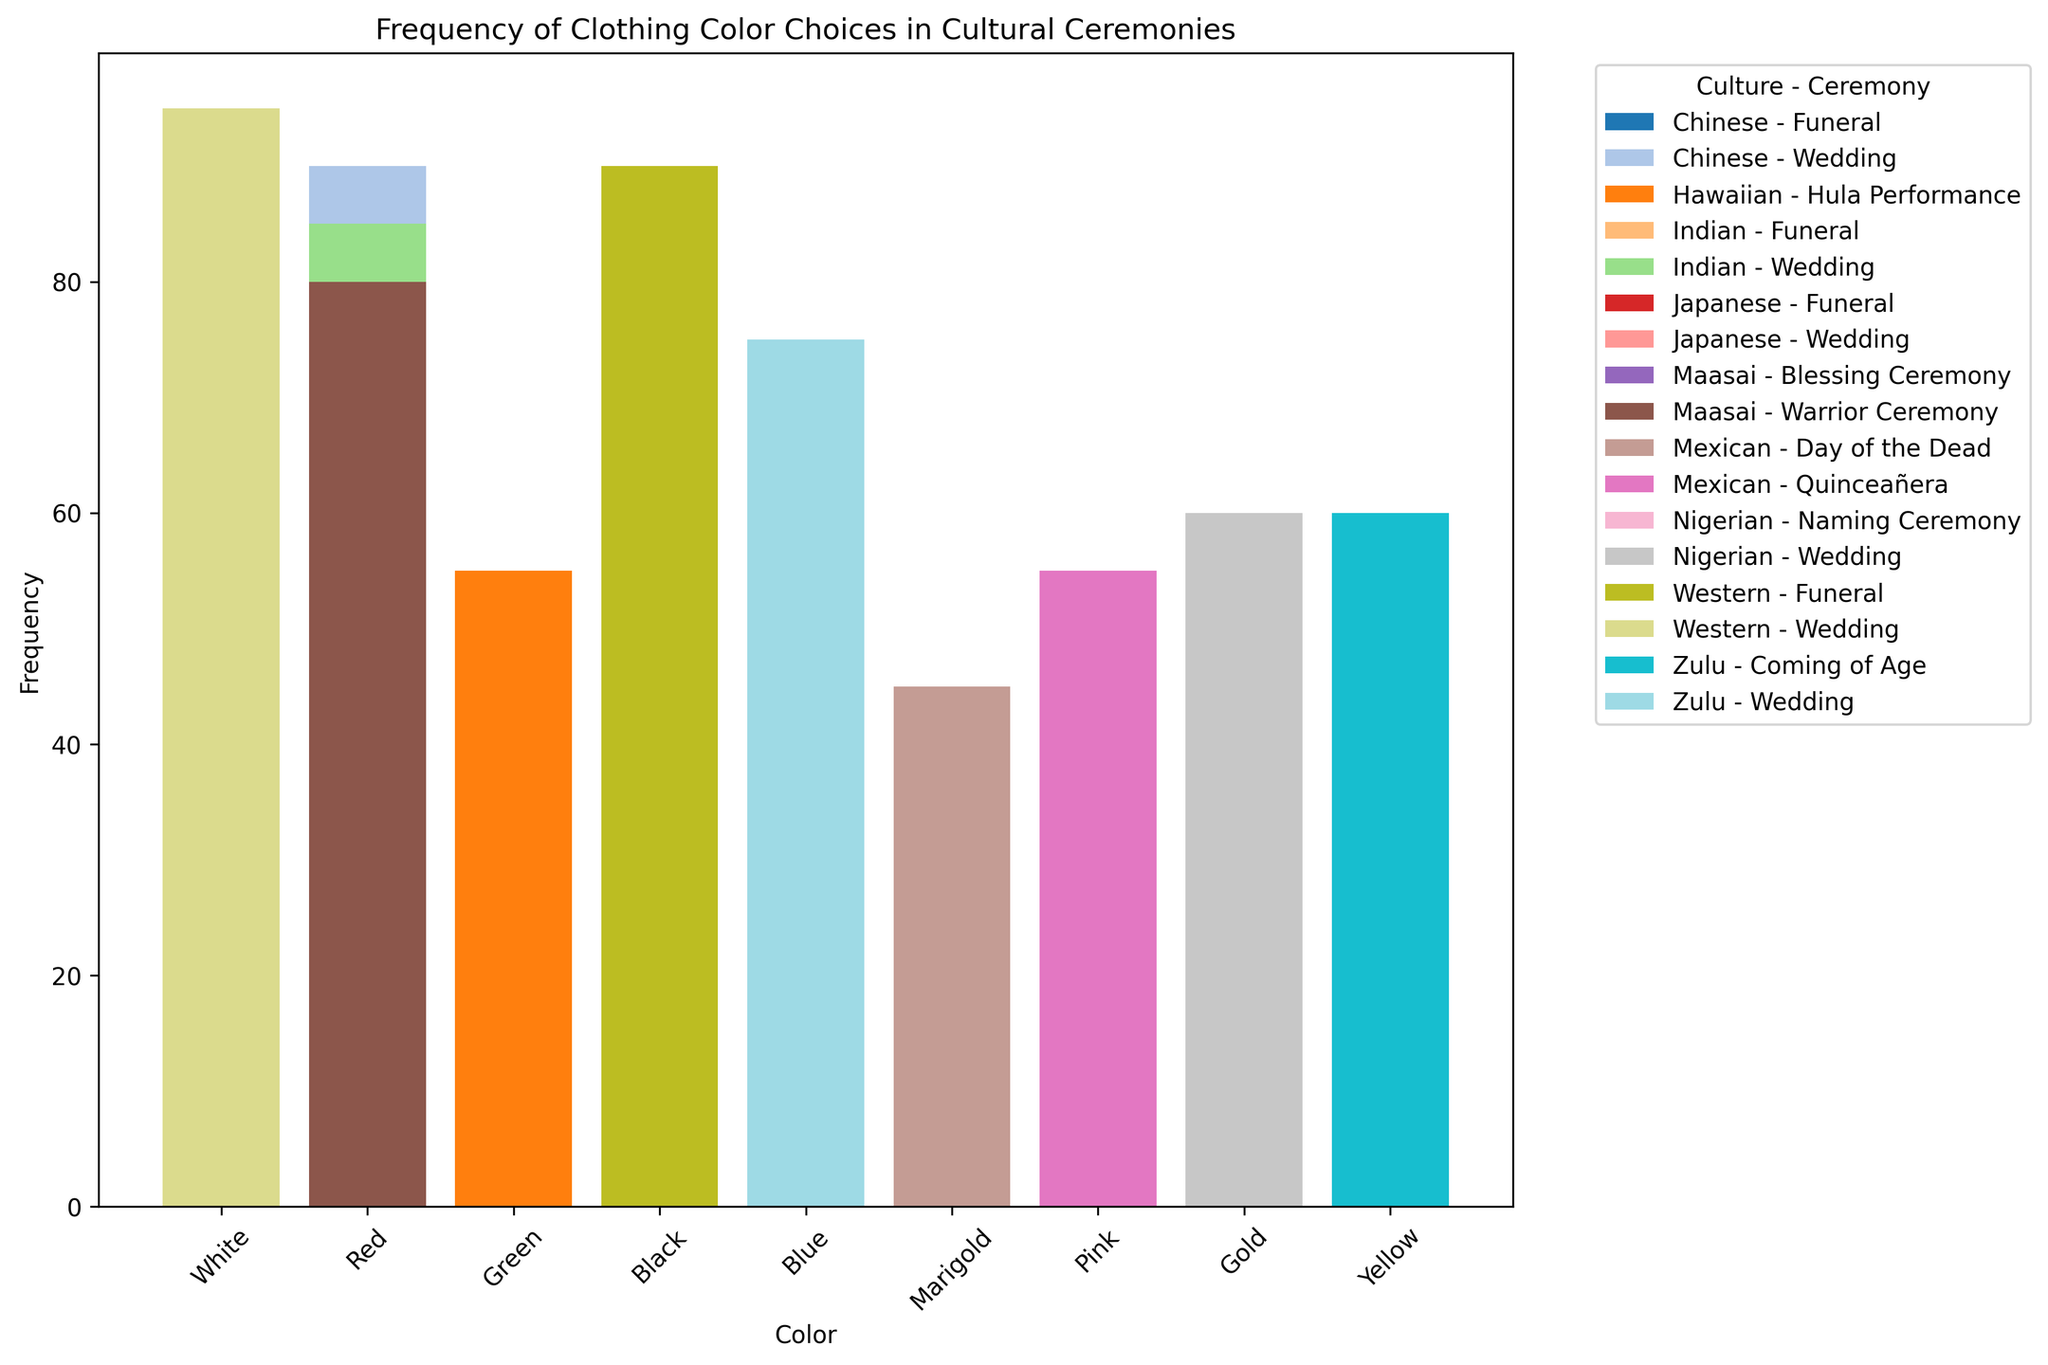Which clothing color is most frequently chosen for Japanese weddings? Identify the bar representing "Japanese - Wedding" and note the color and its height.
Answer: White What is the difference in frequency between Red for Chinese weddings and White for Chinese funerals? Locate the bars labeled "Chinese - Wedding" (Red) and "Chinese - Funeral" (White) and subtract the smaller from the larger value.
Answer: 25 Which color has the highest combined frequency in Indian ceremonies (Wedding and Funeral)? Sum the frequencies of Red in "Indian - Wedding" and White in "Indian - Funeral" and compare with frequencies of other colors across these ceremonies.
Answer: Red Is the frequency of Black in Western funerals higher or lower than that of Black in Japanese funerals? Compare the height of the bars for Black in "Western - Funeral" and Black in "Japanese - Funeral".
Answer: Higher What is the total frequency of White across all ceremonies in all cultures? Locate all bars labeled White in different ceremonies and sum their frequencies.
Answer: 355 How does the frequency of Red in Maasai Warrior Ceremony compare to the frequency of Blue in the same culture's Blessing Ceremony? Compare the height of the bars for Red in "Maasai - Warrior Ceremony" and Blue in "Maasai - Blessing Ceremony".
Answer: Higher What symbolic meaning is associated with the most frequently chosen color for Chinese weddings? Identify the color for "Chinese - Wedding" with the highest frequency and provide its description.
Answer: Prosperity and Joy Which culture uses the color White most frequently in any of its ceremonies? Identify which culture has the tallest bar labeled White in any of their ceremonies.
Answer: Western What is the average frequency of Blue for all ceremonies in the dataset? Identify bars colored Blue and calculate their total frequency, then divide by the number of Blue bars.
Answer: 47.5 How does the frequency of Gold in Nigerian weddings compare to that of Yellow in Zulu coming of age ceremonies? Compare the height of the Gold bar in "Nigerian - Wedding" with the Yellow bar in "Zulu - Coming of Age" ceremony.
Answer: Higher 